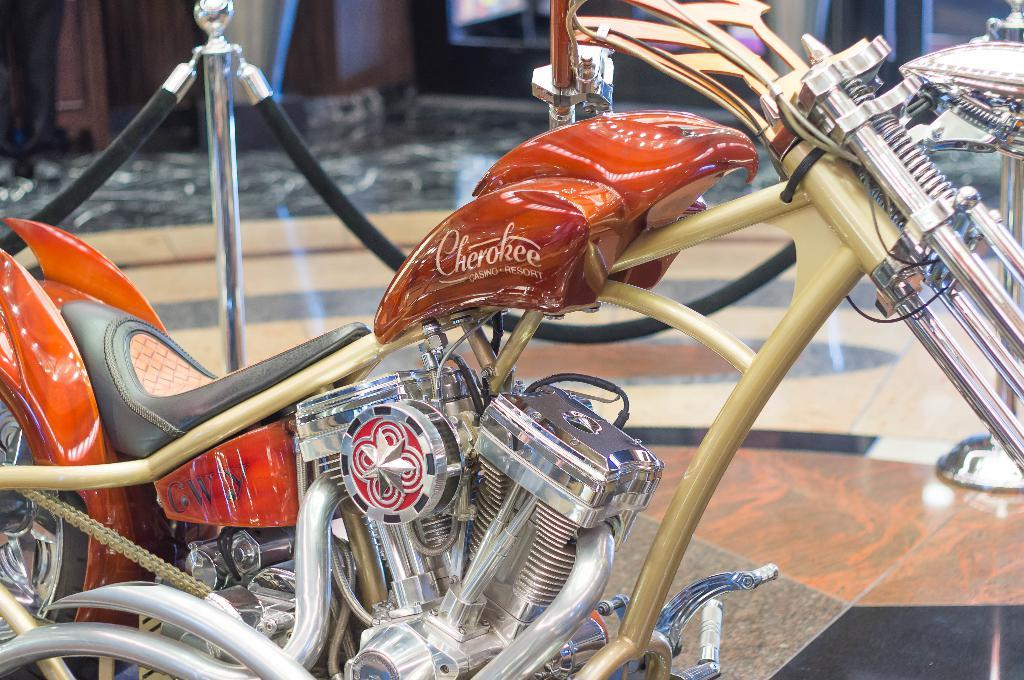What type of vehicle is in the image? There is a motorbike in the image. Where is the motorbike located? The motorbike is on the floor. How is the motorbike secured in the image? The motorbike is protected by ropes. What else is present around the motorbike in the image? The motorbike is surrounded by poles. What type of furniture is depicted in the image? There is no furniture present in the image; it features a motorbike on the floor, protected by ropes and surrounded by poles. 